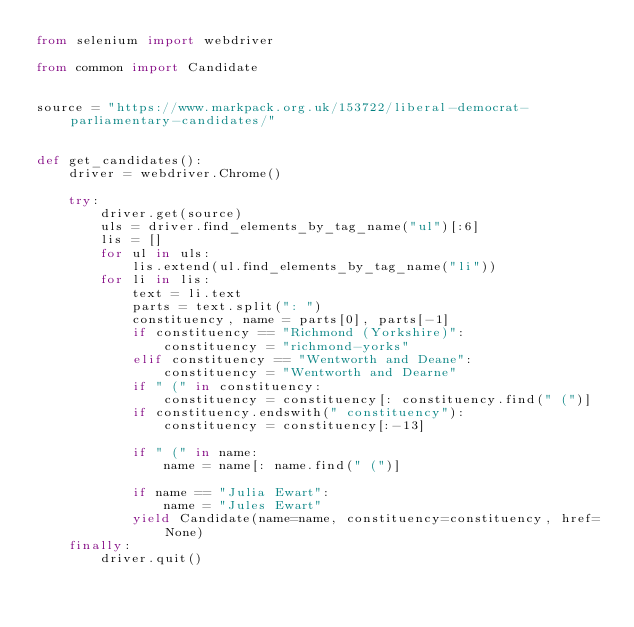Convert code to text. <code><loc_0><loc_0><loc_500><loc_500><_Python_>from selenium import webdriver

from common import Candidate


source = "https://www.markpack.org.uk/153722/liberal-democrat-parliamentary-candidates/"


def get_candidates():
    driver = webdriver.Chrome()

    try:
        driver.get(source)
        uls = driver.find_elements_by_tag_name("ul")[:6]
        lis = []
        for ul in uls:
            lis.extend(ul.find_elements_by_tag_name("li"))
        for li in lis:
            text = li.text
            parts = text.split(": ")
            constituency, name = parts[0], parts[-1]
            if constituency == "Richmond (Yorkshire)":
                constituency = "richmond-yorks"
            elif constituency == "Wentworth and Deane":
                constituency = "Wentworth and Dearne"
            if " (" in constituency:
                constituency = constituency[: constituency.find(" (")]
            if constituency.endswith(" constituency"):
                constituency = constituency[:-13]

            if " (" in name:
                name = name[: name.find(" (")]

            if name == "Julia Ewart":
                name = "Jules Ewart"
            yield Candidate(name=name, constituency=constituency, href=None)
    finally:
        driver.quit()
</code> 